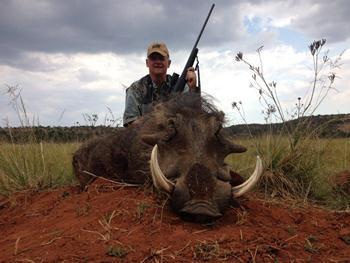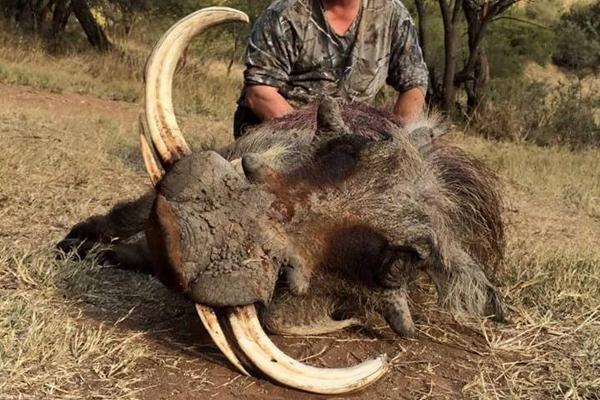The first image is the image on the left, the second image is the image on the right. Evaluate the accuracy of this statement regarding the images: "there is exactly one human in the image on the left". Is it true? Answer yes or no. Yes. The first image is the image on the left, the second image is the image on the right. Examine the images to the left and right. Is the description "The image on the left shows a hunter wearing a hat and posing with his prey." accurate? Answer yes or no. Yes. 